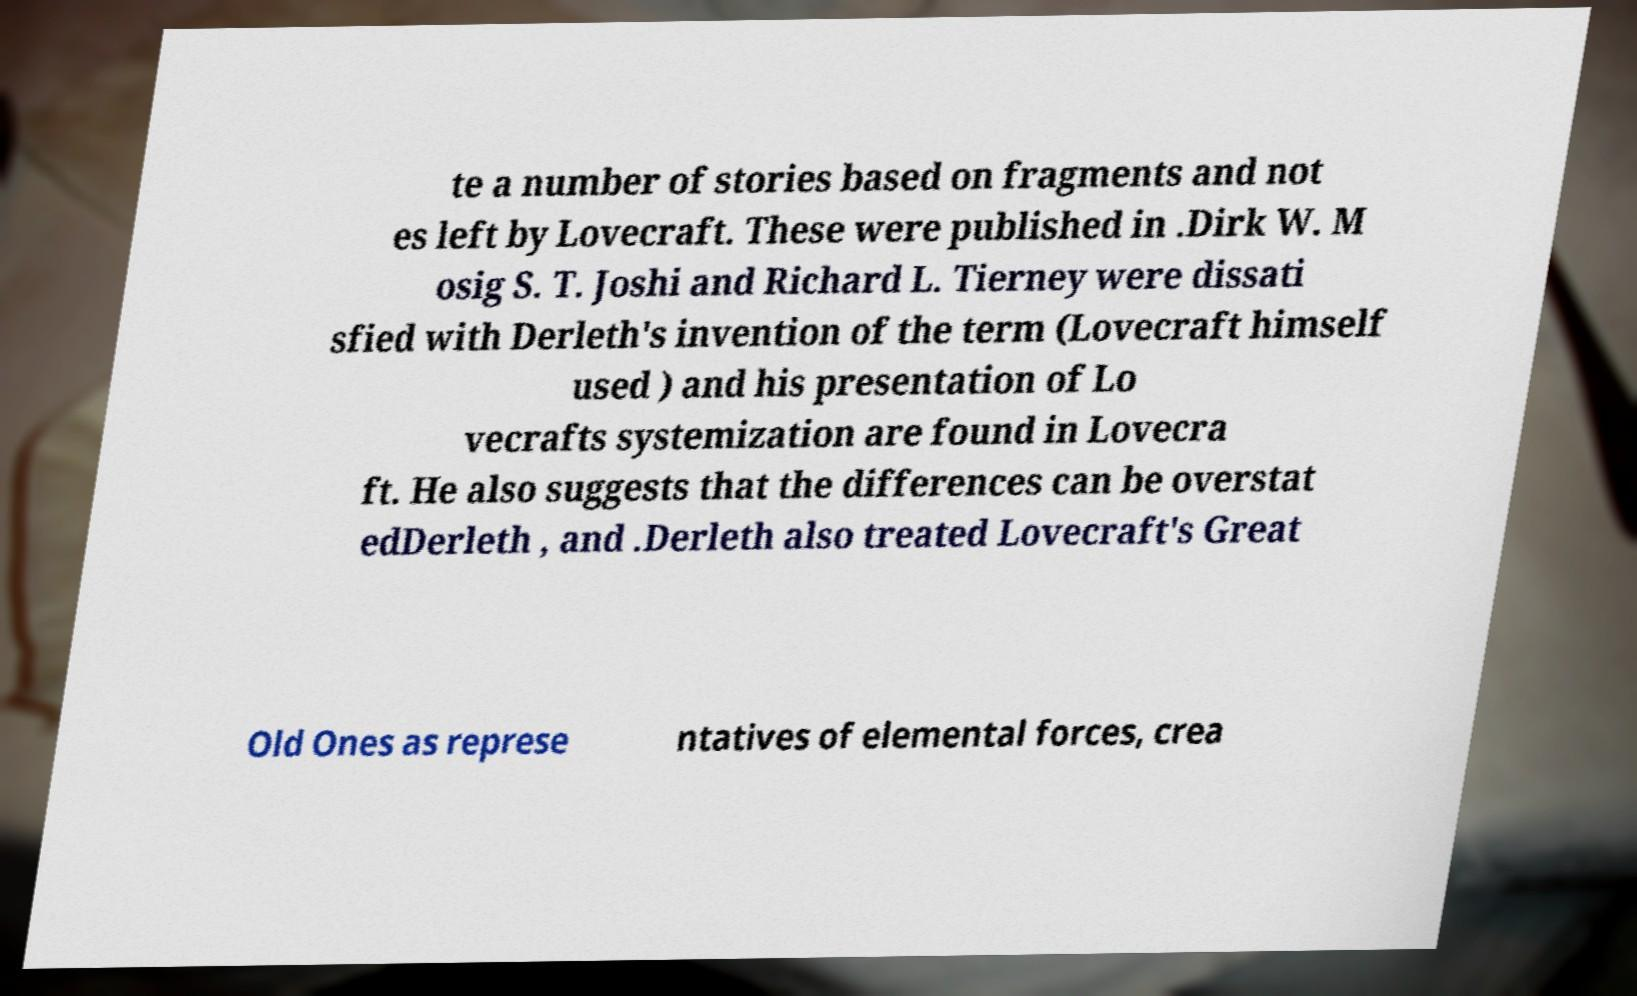Could you assist in decoding the text presented in this image and type it out clearly? te a number of stories based on fragments and not es left by Lovecraft. These were published in .Dirk W. M osig S. T. Joshi and Richard L. Tierney were dissati sfied with Derleth's invention of the term (Lovecraft himself used ) and his presentation of Lo vecrafts systemization are found in Lovecra ft. He also suggests that the differences can be overstat edDerleth , and .Derleth also treated Lovecraft's Great Old Ones as represe ntatives of elemental forces, crea 